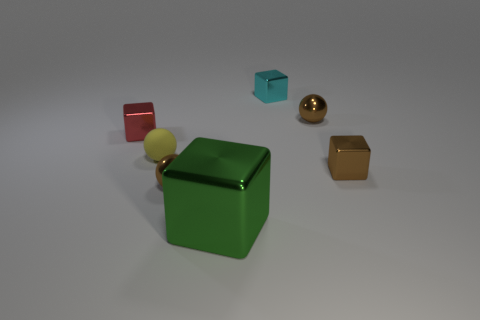Are there any other things that are the same material as the yellow object?
Offer a terse response. No. There is a small object that is to the right of the tiny cyan object and in front of the tiny yellow object; what color is it?
Provide a short and direct response. Brown. What number of objects are either metal blocks that are on the left side of the tiny yellow matte object or metallic cubes?
Offer a terse response. 4. What number of other things are the same color as the matte ball?
Offer a very short reply. 0. Are there an equal number of small red metal things that are behind the small brown metal cube and big brown shiny spheres?
Your answer should be very brief. No. What number of tiny cyan objects are in front of the brown metal ball on the right side of the brown thing that is in front of the small brown shiny block?
Give a very brief answer. 0. Is there anything else that has the same size as the cyan cube?
Ensure brevity in your answer.  Yes. Do the red metallic block and the metal ball in front of the small matte sphere have the same size?
Your answer should be very brief. Yes. How many red matte cubes are there?
Offer a terse response. 0. There is a brown shiny thing behind the yellow ball; is it the same size as the brown shiny ball to the left of the cyan shiny block?
Your answer should be very brief. Yes. 